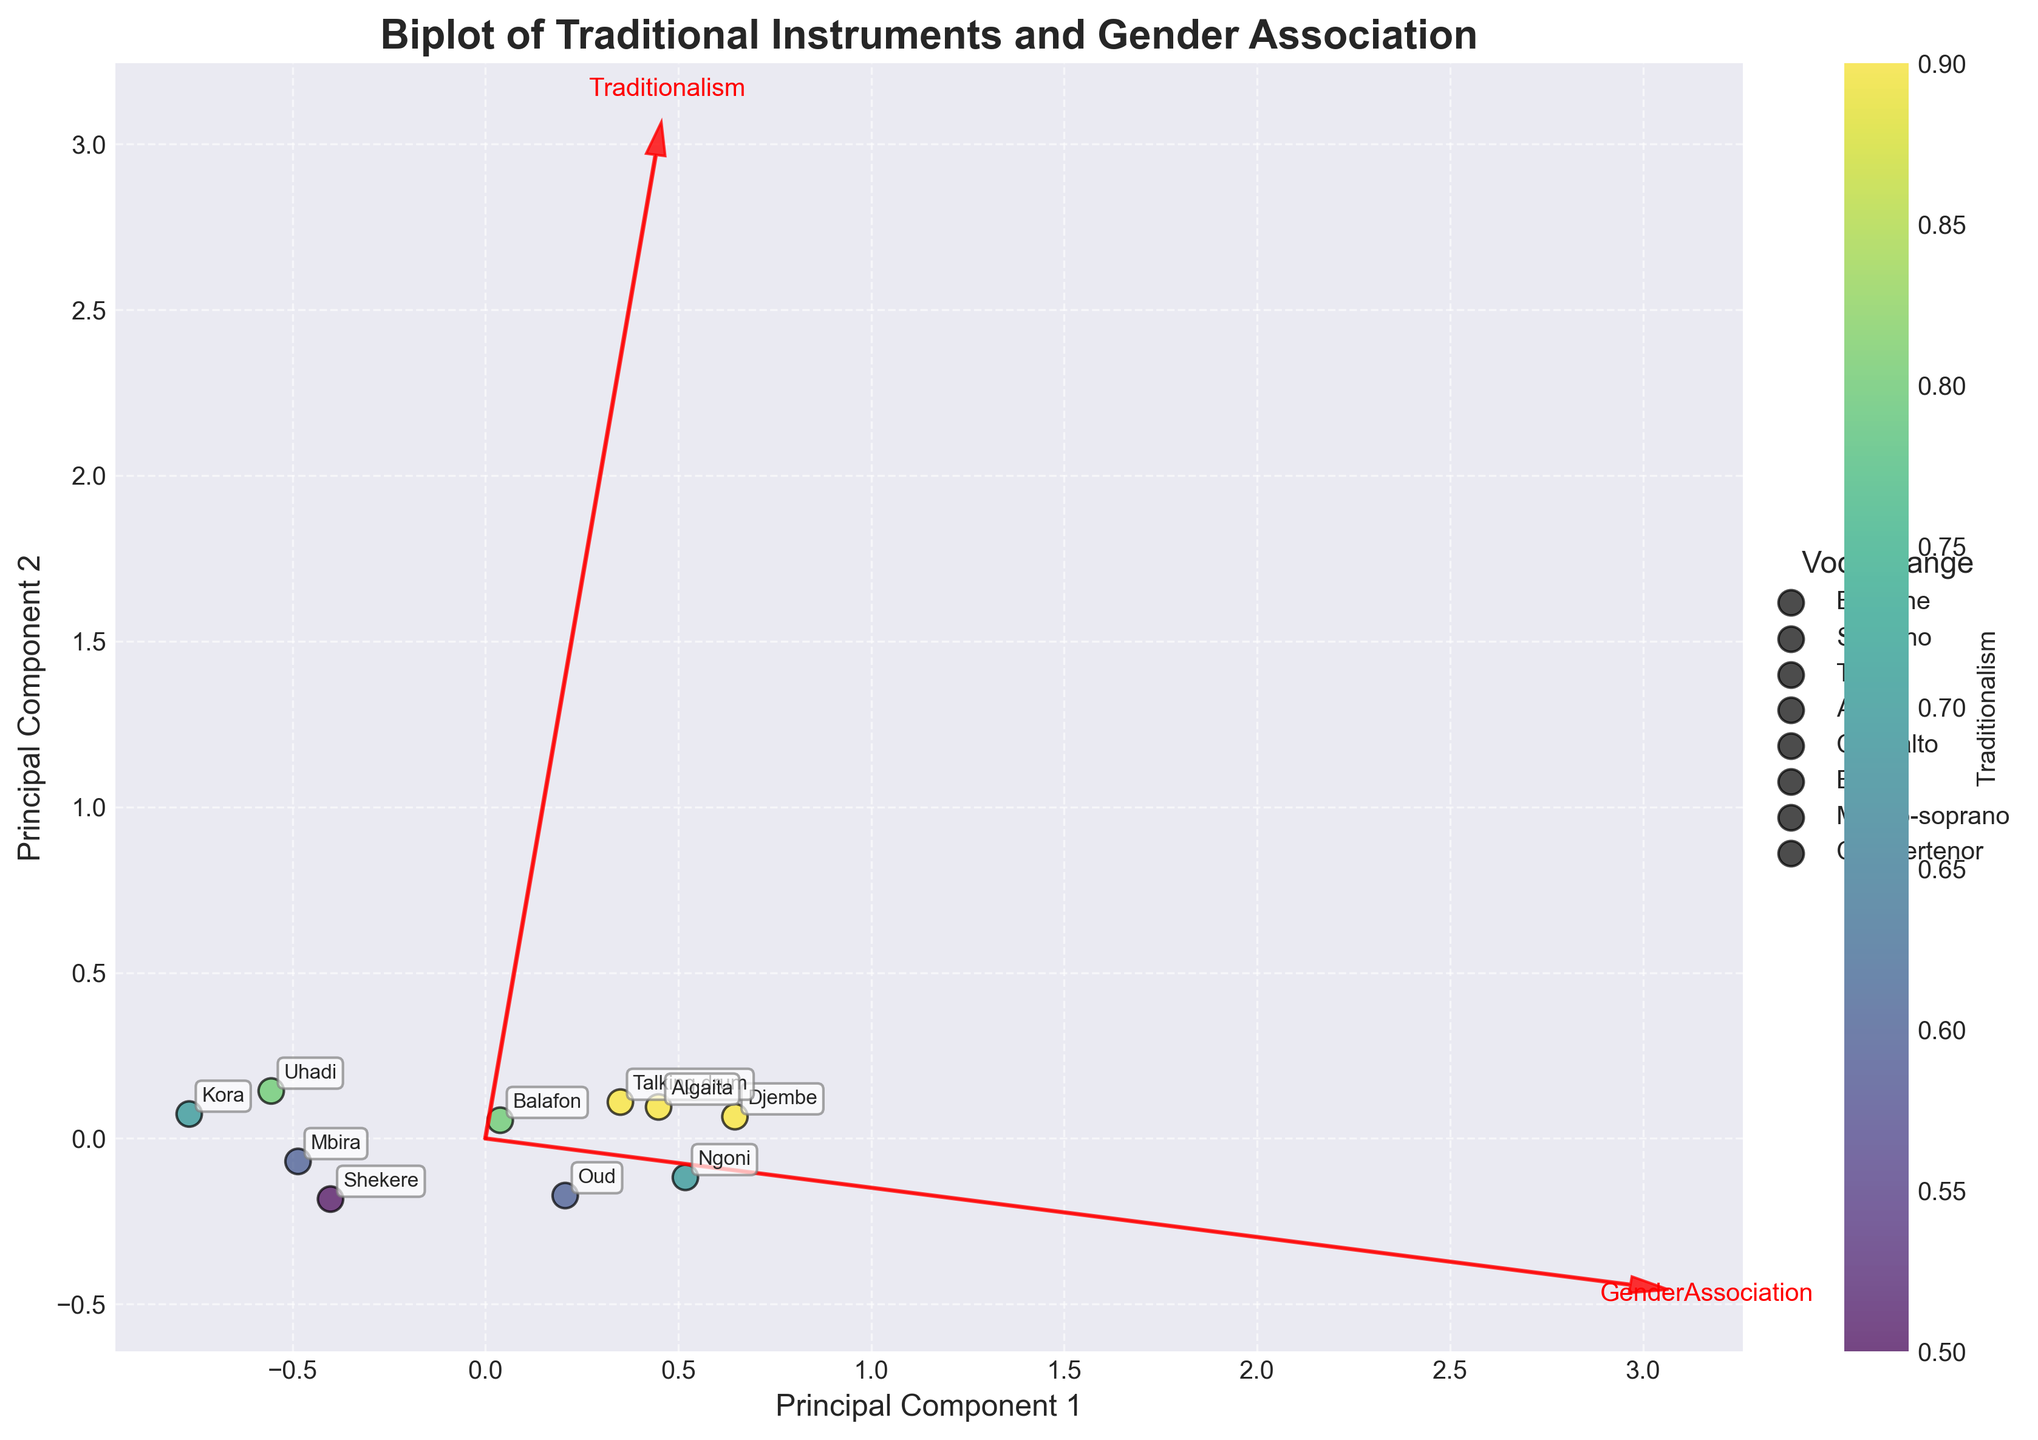What's the title of the plot? The title is present at the top of the plot with a bold and larger font than other texts.
Answer: Biplot of Traditional Instruments and Gender Association How many vocal ranges are indicated in the legend? The legend shows a different icon for each vocal range. Count these unique entries.
Answer: 8 Which instrument is closest to the 'Traditionalism' vector? Look at the position of the data points and find the one nearest to the red arrow representing 'Traditionalism'.
Answer: Algaita Is there a positive or negative relationship between Traditionalism and GenderAssociation? Examine the direction of the 'Traditionalism' and 'GenderAssociation' vectors. If both arrows point in similar directions, it's positive; otherwise, it's negative.
Answer: Negative Which principal component contributes more to traditionalism, PC1 or PC2? Look at the 'Traditionalism' arrow and assess whether it aligns more closely with the x-axis (PC1) or y-axis (PC2).
Answer: PC1 What is the color of the point representing Kora, and what does this color signify? Locate the Kora point and observe its color. Check the color bar to interpret what the color represents.
Answer: Yellow-green, indicating moderate traditionalism Among the vocal ranges, which one appears to be associated with higher traditionalism values? Compare the colors of points associated with different vocal ranges, paying attention to those with higher traditionalism (darker colors on the color bar).
Answer: Baritone and Soprano Which instrument is further from the center of the biplot, Djembe or Shekere? Measure the distance from the center (0, 0) to the points representing Djembe and Shekere, and see which is further away.
Answer: Djembe Are there any instruments whose GenderAssociation aligns negatively with Traditionalism? Identify instruments located in the opposite quadrant relative to the 'Traditionalism' and 'GenderAssociation' arrows.
Answer: Kora, Uhadi, Mbira, Shekere 